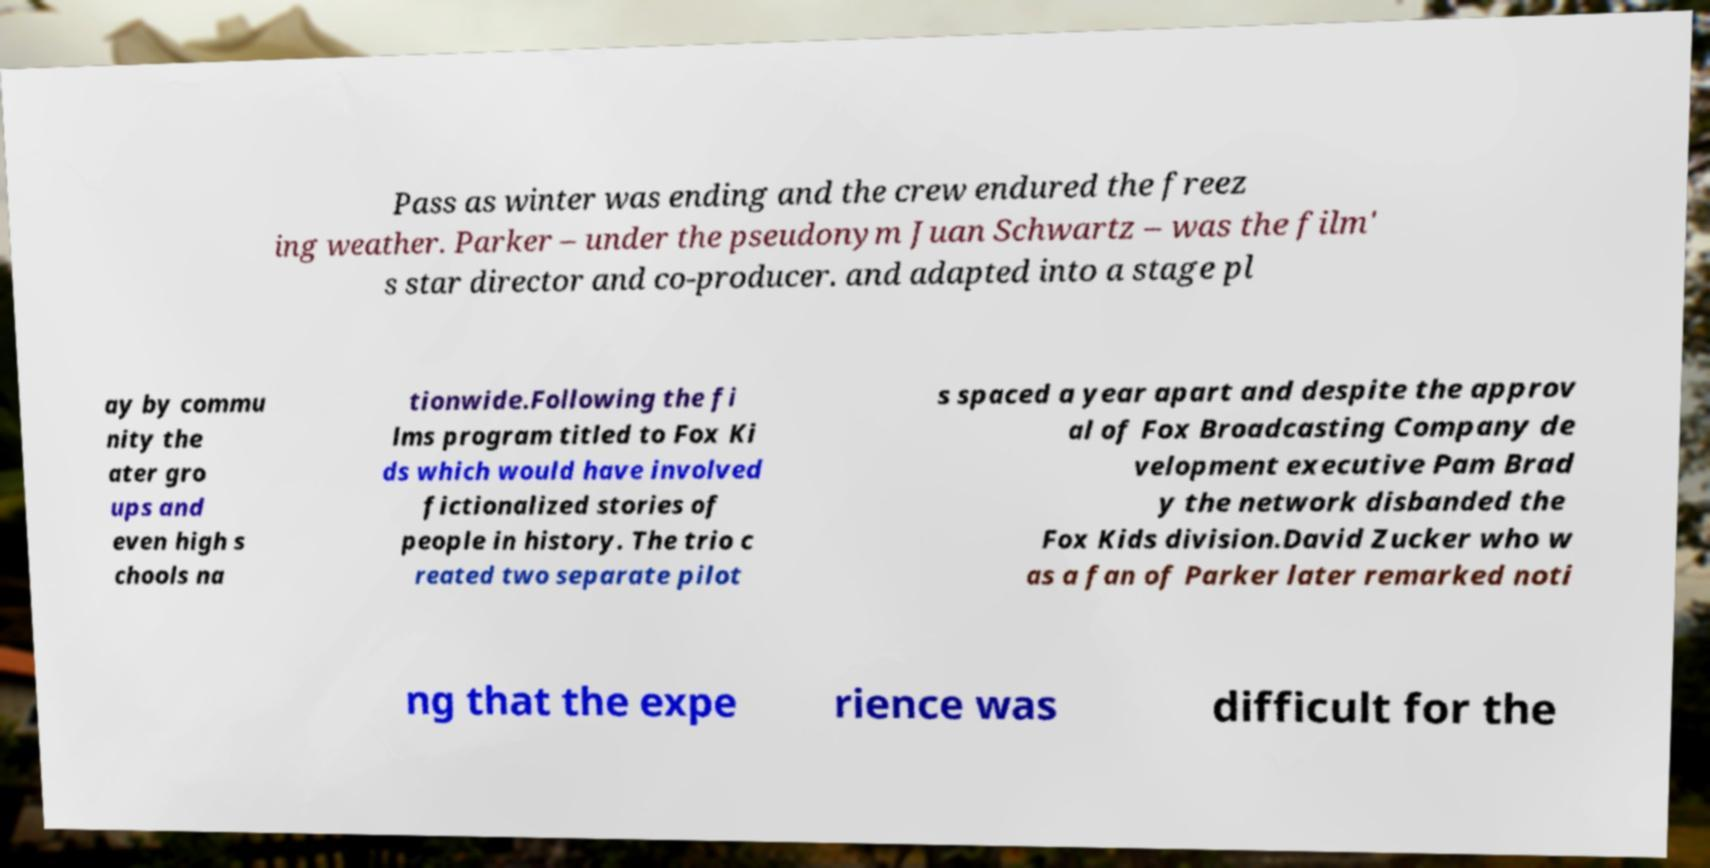Could you extract and type out the text from this image? Pass as winter was ending and the crew endured the freez ing weather. Parker – under the pseudonym Juan Schwartz – was the film' s star director and co-producer. and adapted into a stage pl ay by commu nity the ater gro ups and even high s chools na tionwide.Following the fi lms program titled to Fox Ki ds which would have involved fictionalized stories of people in history. The trio c reated two separate pilot s spaced a year apart and despite the approv al of Fox Broadcasting Company de velopment executive Pam Brad y the network disbanded the Fox Kids division.David Zucker who w as a fan of Parker later remarked noti ng that the expe rience was difficult for the 